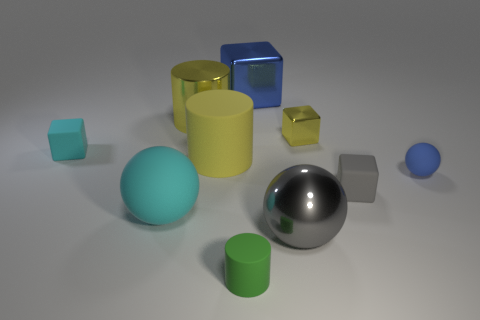How many tiny red metallic spheres are there?
Provide a short and direct response. 0. Do the rubber cube that is on the right side of the tiny metallic thing and the shiny thing behind the big shiny cylinder have the same color?
Offer a terse response. No. How many shiny cubes are in front of the yellow matte cylinder?
Your answer should be very brief. 0. There is a block that is the same color as the small rubber sphere; what is its material?
Provide a succinct answer. Metal. Is there a small yellow thing of the same shape as the small gray object?
Ensure brevity in your answer.  Yes. Do the large yellow cylinder behind the small shiny object and the blue object behind the small cyan rubber block have the same material?
Provide a succinct answer. Yes. How big is the sphere that is on the left side of the tiny object that is in front of the cyan matte object in front of the tiny blue matte thing?
Make the answer very short. Large. There is a blue sphere that is the same size as the gray block; what material is it?
Your answer should be compact. Rubber. Are there any gray rubber things that have the same size as the metal sphere?
Offer a very short reply. No. Is the gray shiny object the same shape as the small gray thing?
Your response must be concise. No. 